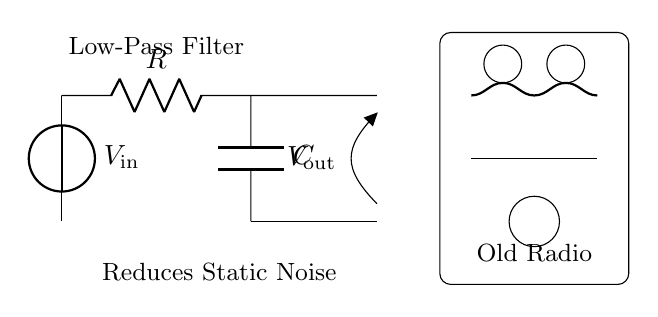What is the function of the resistor in this circuit? The resistor is used to limit current as part of the low-pass filter configuration. It is essential in controlling the interaction between the resistor and capacitor to allow low-frequency signals to pass while attenuating high-frequency noise.
Answer: Limit current What component is used alongside the resistor in this filter? The component used alongside the resistor is the capacitor. The combination of the resistor and capacitor forms the low-pass filter, which allows certain frequencies to pass through while blocking others.
Answer: Capacitor What is the output voltage in relation to the input voltage? The output voltage is expressed as V out, which is taken from the junction between the resistor and the capacitor. It reflects the effect of the low-pass filter on the input voltage, demonstrating a reduction in high-frequency noise.
Answer: V out What type of filter is represented in this circuit? The circuit represents a low-pass filter, designed to allow low-frequency signals to pass while reducing unwanted high-frequency static noise in the radio.
Answer: Low-pass filter How does the low-pass filter affect static noise? The low-pass filter attenuates the high-frequency components of static noise, allowing only lower-frequency signals to pass through clearly, which improves the audio output quality of the radio.
Answer: Reduces static noise What is the importance of the low-pass filter in an old-fashioned radio? The low-pass filter is crucial for improving sound quality by minimizing static and other high-frequency interferences, ensuring a clearer and more enjoyable listening experience.
Answer: Improves sound quality 